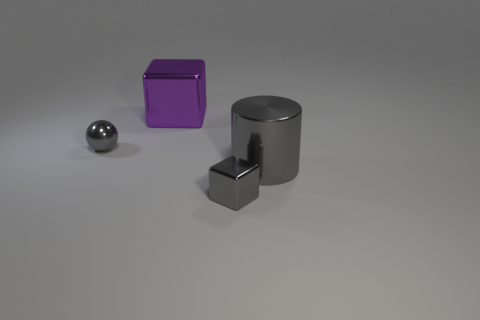How many metal cubes are the same color as the tiny metal ball?
Your answer should be compact. 1. Are any big cylinders visible?
Your response must be concise. Yes. Is the shape of the big gray metallic thing the same as the object that is behind the small sphere?
Make the answer very short. No. What color is the thing on the left side of the large metal thing that is behind the tiny gray object that is on the left side of the big purple thing?
Give a very brief answer. Gray. Are there any gray shiny balls in front of the metal sphere?
Ensure brevity in your answer.  No. There is a sphere that is the same color as the large metallic cylinder; what size is it?
Keep it short and to the point. Small. Is there another gray cylinder that has the same material as the gray cylinder?
Give a very brief answer. No. What color is the cylinder?
Offer a terse response. Gray. Is the shape of the tiny shiny thing that is behind the large shiny cylinder the same as  the large gray metallic thing?
Offer a terse response. No. There is a big object that is on the right side of the small thing to the right of the cube behind the tiny gray ball; what shape is it?
Your answer should be compact. Cylinder. 